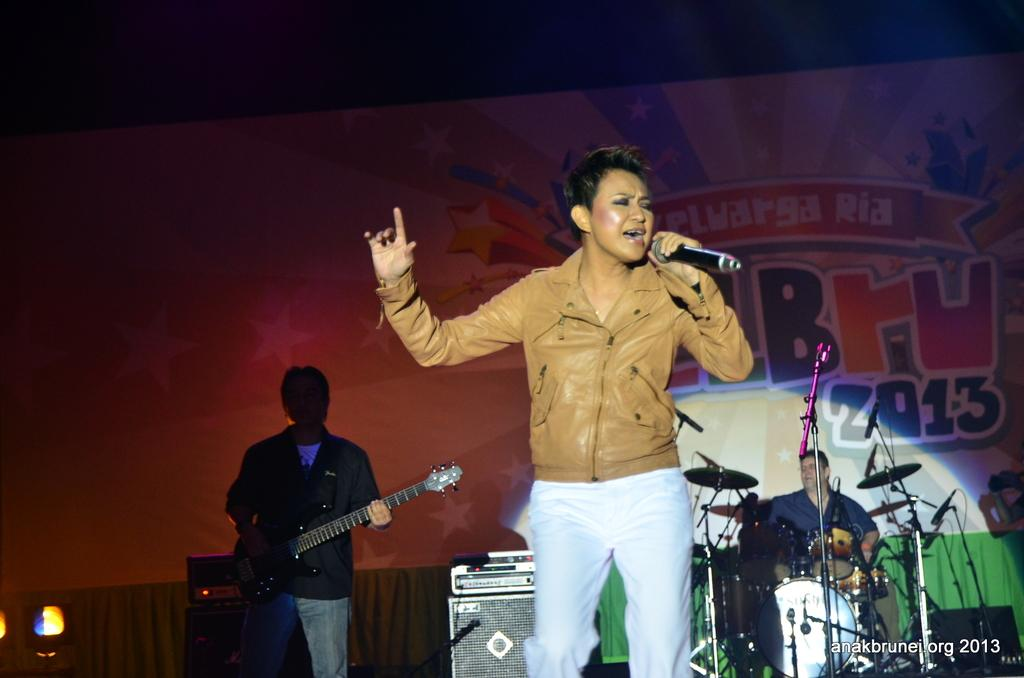How many people are in the image? There are three persons in the image. What is one person doing in the image? One person is holding a mic. What are the other two persons doing in the image? The other two persons are playing musical instruments. What type of edge can be seen on the basket in the image? There is no basket present in the image, so there is no edge to describe. 